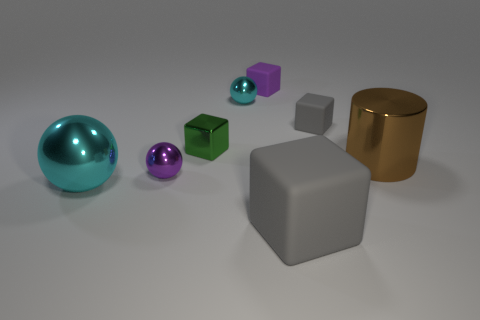Are there an equal number of small gray matte blocks that are in front of the tiny green metallic object and tiny metal things?
Give a very brief answer. No. Do the gray rubber cube that is in front of the purple sphere and the large ball have the same size?
Your answer should be very brief. Yes. What color is the other sphere that is the same size as the purple metallic sphere?
Provide a short and direct response. Cyan. Is there a large ball that is behind the large thing left of the small purple thing on the right side of the small cyan metal object?
Ensure brevity in your answer.  No. What is the cyan object that is behind the big cyan metallic sphere made of?
Your answer should be very brief. Metal. There is a big brown shiny object; is it the same shape as the green object that is to the left of the purple rubber thing?
Offer a terse response. No. Are there an equal number of large cyan metallic objects behind the tiny cyan thing and cylinders that are on the right side of the tiny purple matte object?
Provide a succinct answer. No. How many other things are there of the same material as the big cyan ball?
Ensure brevity in your answer.  4. What number of metallic objects are either small objects or tiny gray blocks?
Your response must be concise. 3. There is a matte thing that is in front of the green object; is its shape the same as the brown metal object?
Your answer should be compact. No. 